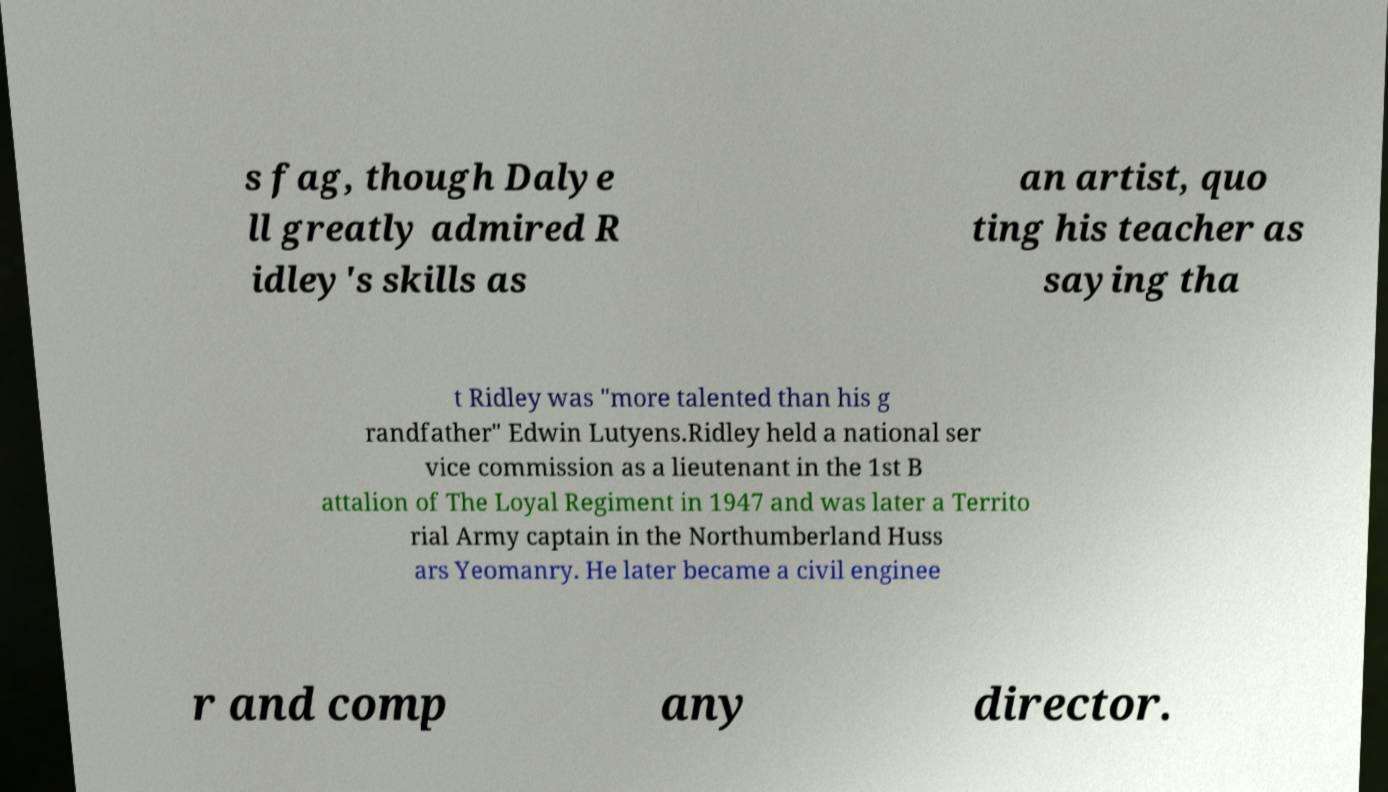Could you extract and type out the text from this image? s fag, though Dalye ll greatly admired R idley's skills as an artist, quo ting his teacher as saying tha t Ridley was "more talented than his g randfather" Edwin Lutyens.Ridley held a national ser vice commission as a lieutenant in the 1st B attalion of The Loyal Regiment in 1947 and was later a Territo rial Army captain in the Northumberland Huss ars Yeomanry. He later became a civil enginee r and comp any director. 